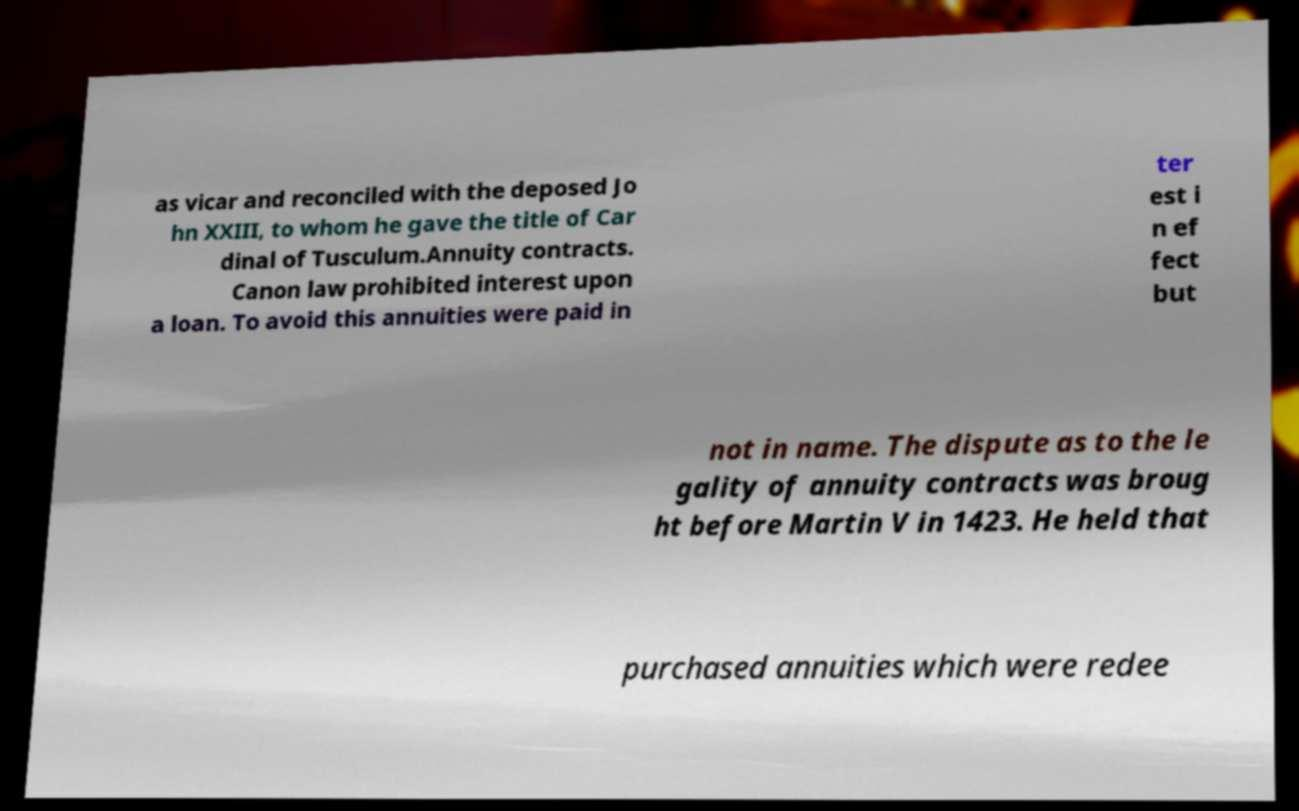Can you read and provide the text displayed in the image?This photo seems to have some interesting text. Can you extract and type it out for me? as vicar and reconciled with the deposed Jo hn XXIII, to whom he gave the title of Car dinal of Tusculum.Annuity contracts. Canon law prohibited interest upon a loan. To avoid this annuities were paid in ter est i n ef fect but not in name. The dispute as to the le gality of annuity contracts was broug ht before Martin V in 1423. He held that purchased annuities which were redee 